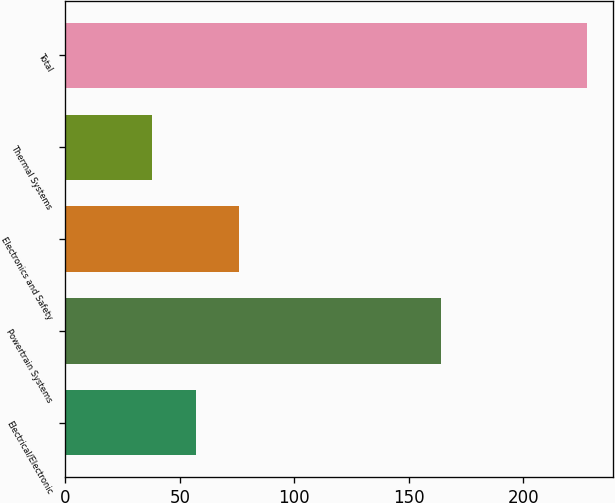Convert chart to OTSL. <chart><loc_0><loc_0><loc_500><loc_500><bar_chart><fcel>Electrical/Electronic<fcel>Powertrain Systems<fcel>Electronics and Safety<fcel>Thermal Systems<fcel>Total<nl><fcel>57<fcel>164<fcel>76<fcel>38<fcel>228<nl></chart> 